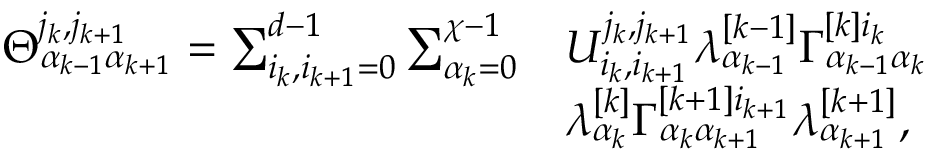Convert formula to latex. <formula><loc_0><loc_0><loc_500><loc_500>\begin{array} { r l } { \Theta _ { \alpha _ { k - 1 } \alpha _ { k + 1 } } ^ { j _ { k } , j _ { k + 1 } } = \sum _ { i _ { k } , i _ { k + 1 } = 0 } ^ { d - 1 } \sum _ { \alpha _ { k } = 0 } ^ { \chi - 1 } } & { U _ { i _ { k } , i _ { k + 1 } } ^ { j _ { k } , j _ { k + 1 } } \lambda _ { \alpha _ { k - 1 } } ^ { [ k - 1 ] } \Gamma _ { \alpha _ { k - 1 } \alpha _ { k } } ^ { [ k ] i _ { k } } } \\ & { \lambda _ { \alpha _ { k } } ^ { [ k ] } \Gamma _ { \alpha _ { k } \alpha _ { k + 1 } } ^ { [ k + 1 ] i _ { k + 1 } } \lambda _ { \alpha _ { k + 1 } } ^ { [ k + 1 ] } , } \end{array}</formula> 